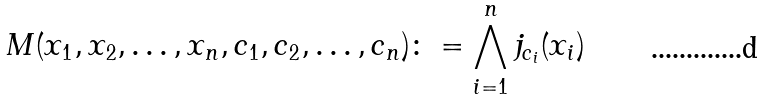<formula> <loc_0><loc_0><loc_500><loc_500>M ( x _ { 1 } , x _ { 2 } , \dots , x _ { n } , c _ { 1 } , c _ { 2 } , \dots , c _ { n } ) \colon = \bigwedge _ { i = 1 } ^ { n } j _ { c _ { i } } ( x _ { i } )</formula> 